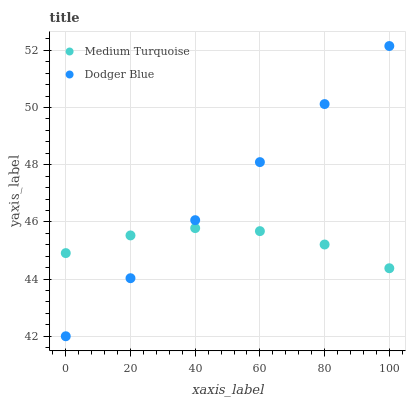Does Medium Turquoise have the minimum area under the curve?
Answer yes or no. Yes. Does Dodger Blue have the maximum area under the curve?
Answer yes or no. Yes. Does Medium Turquoise have the maximum area under the curve?
Answer yes or no. No. Is Dodger Blue the smoothest?
Answer yes or no. Yes. Is Medium Turquoise the roughest?
Answer yes or no. Yes. Is Medium Turquoise the smoothest?
Answer yes or no. No. Does Dodger Blue have the lowest value?
Answer yes or no. Yes. Does Medium Turquoise have the lowest value?
Answer yes or no. No. Does Dodger Blue have the highest value?
Answer yes or no. Yes. Does Medium Turquoise have the highest value?
Answer yes or no. No. Does Dodger Blue intersect Medium Turquoise?
Answer yes or no. Yes. Is Dodger Blue less than Medium Turquoise?
Answer yes or no. No. Is Dodger Blue greater than Medium Turquoise?
Answer yes or no. No. 